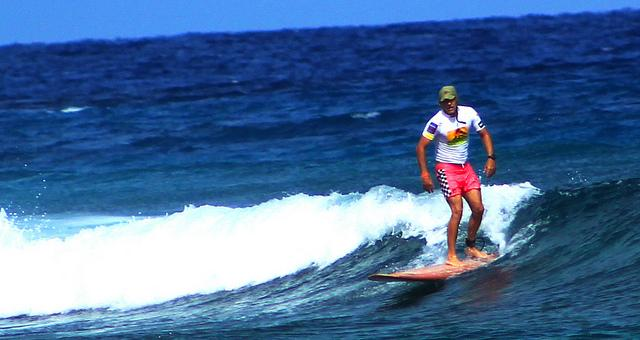What might he have applied before going out there? Please explain your reasoning. sunscreen. The man is surfing wearing swim trunks and short sleeves. he may have applied lotion or oil to his skin to help protect him from the harmful rays of the sun. 